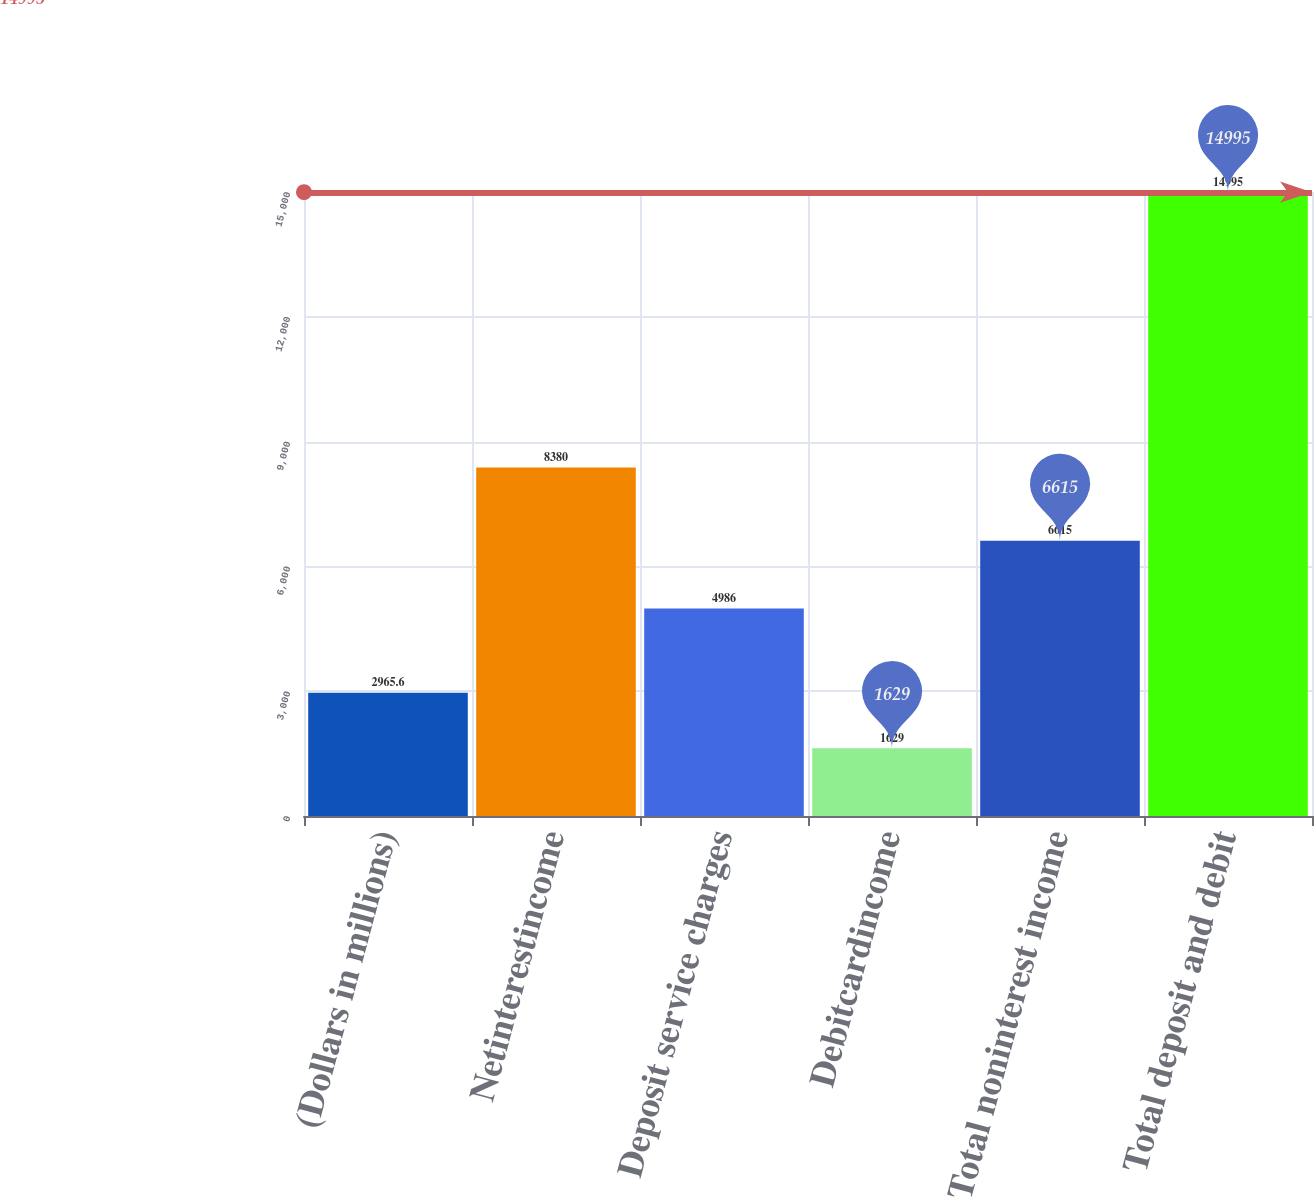Convert chart to OTSL. <chart><loc_0><loc_0><loc_500><loc_500><bar_chart><fcel>(Dollars in millions)<fcel>Netinterestincome<fcel>Deposit service charges<fcel>Debitcardincome<fcel>Total noninterest income<fcel>Total deposit and debit<nl><fcel>2965.6<fcel>8380<fcel>4986<fcel>1629<fcel>6615<fcel>14995<nl></chart> 